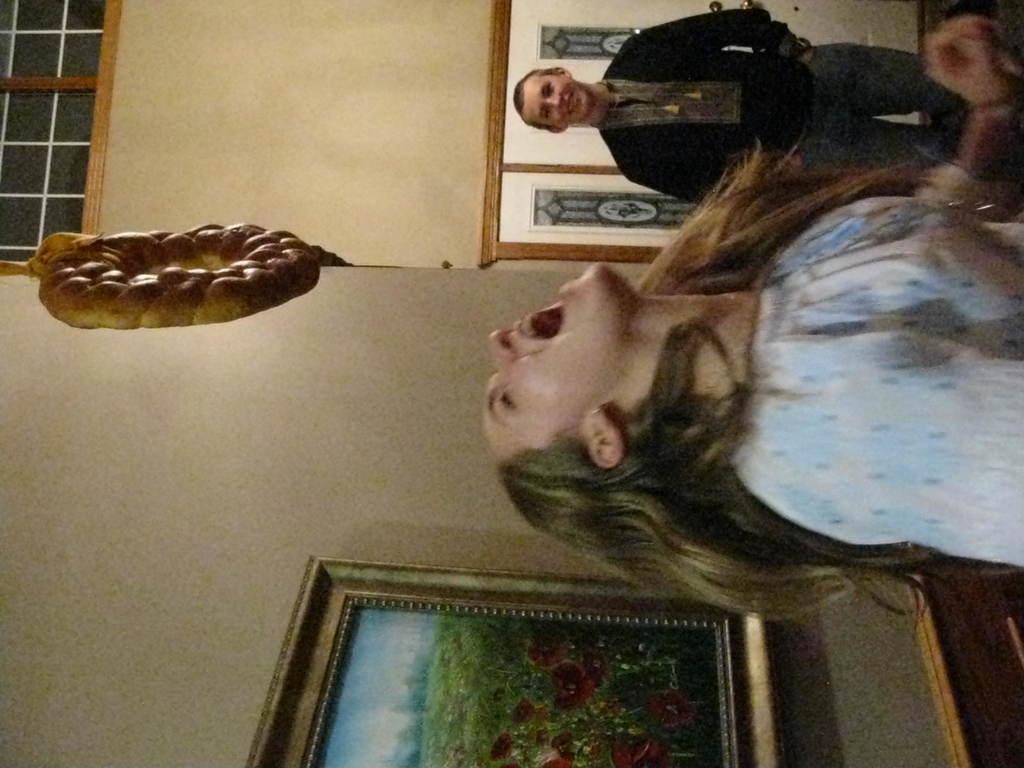Could you give a brief overview of what you see in this image? In the picture we can see a woman standing and looking up and shouting and behind her we can see a wall with photo frame and painting in it and beside her we can see a man standing near the wall and smiling. 